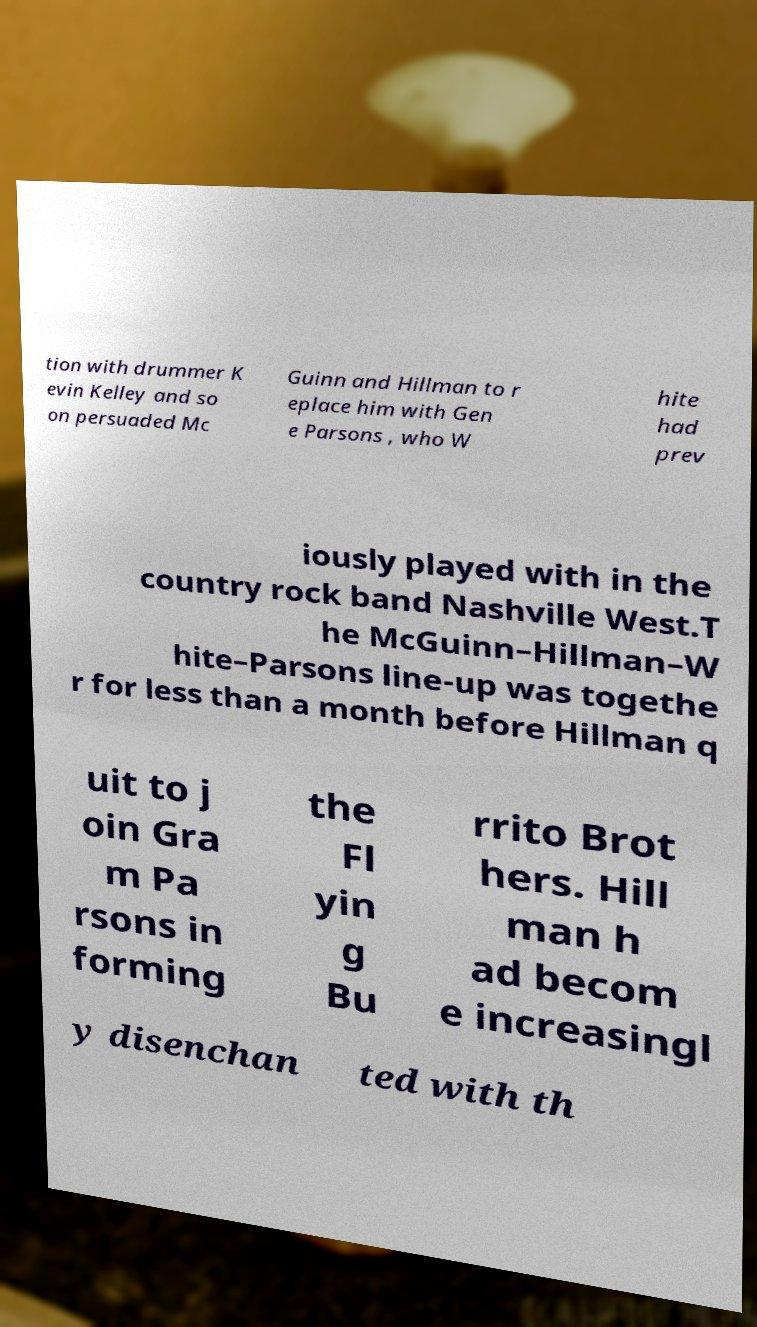Can you read and provide the text displayed in the image?This photo seems to have some interesting text. Can you extract and type it out for me? tion with drummer K evin Kelley and so on persuaded Mc Guinn and Hillman to r eplace him with Gen e Parsons , who W hite had prev iously played with in the country rock band Nashville West.T he McGuinn–Hillman–W hite–Parsons line-up was togethe r for less than a month before Hillman q uit to j oin Gra m Pa rsons in forming the Fl yin g Bu rrito Brot hers. Hill man h ad becom e increasingl y disenchan ted with th 